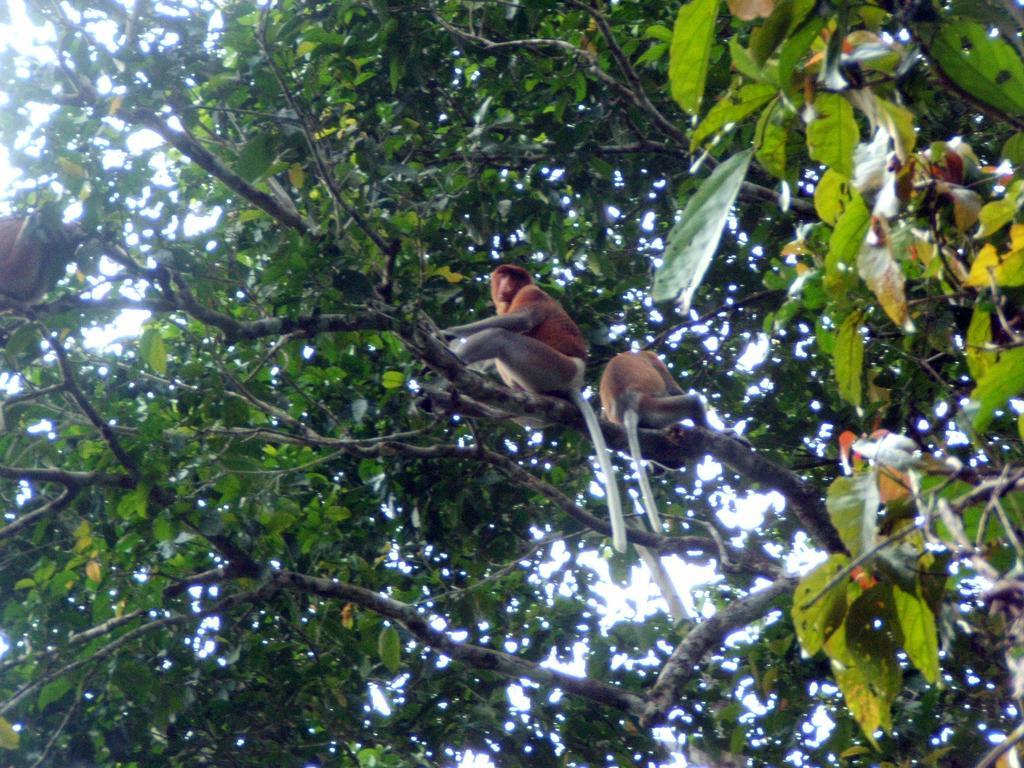How would you summarize this image in a sentence or two? In this picture we can see trees and on trees monkeys are sitting on it and we can see sky. 